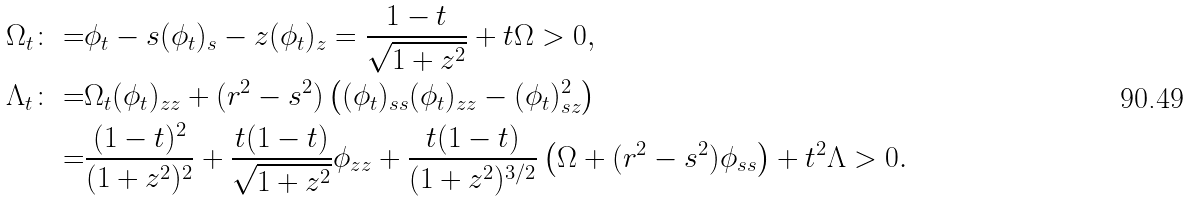<formula> <loc_0><loc_0><loc_500><loc_500>\Omega _ { t } \colon = & \phi _ { t } - s ( \phi _ { t } ) _ { s } - z ( \phi _ { t } ) _ { z } = \frac { 1 - t } { \sqrt { 1 + z ^ { 2 } } } + t \Omega > 0 , \\ \Lambda _ { t } \colon = & \Omega _ { t } ( \phi _ { t } ) _ { z z } + ( r ^ { 2 } - s ^ { 2 } ) \left ( ( \phi _ { t } ) _ { s s } ( \phi _ { t } ) _ { z z } - ( \phi _ { t } ) ^ { 2 } _ { s z } \right ) \\ = & \frac { ( 1 - t ) ^ { 2 } } { ( 1 + z ^ { 2 } ) ^ { 2 } } + \frac { t ( 1 - t ) } { \sqrt { 1 + z ^ { 2 } } } \phi _ { z z } + \frac { t ( 1 - t ) } { ( 1 + z ^ { 2 } ) ^ { 3 / 2 } } \left ( \Omega + ( r ^ { 2 } - s ^ { 2 } ) \phi _ { s s } \right ) + t ^ { 2 } \Lambda > 0 .</formula> 